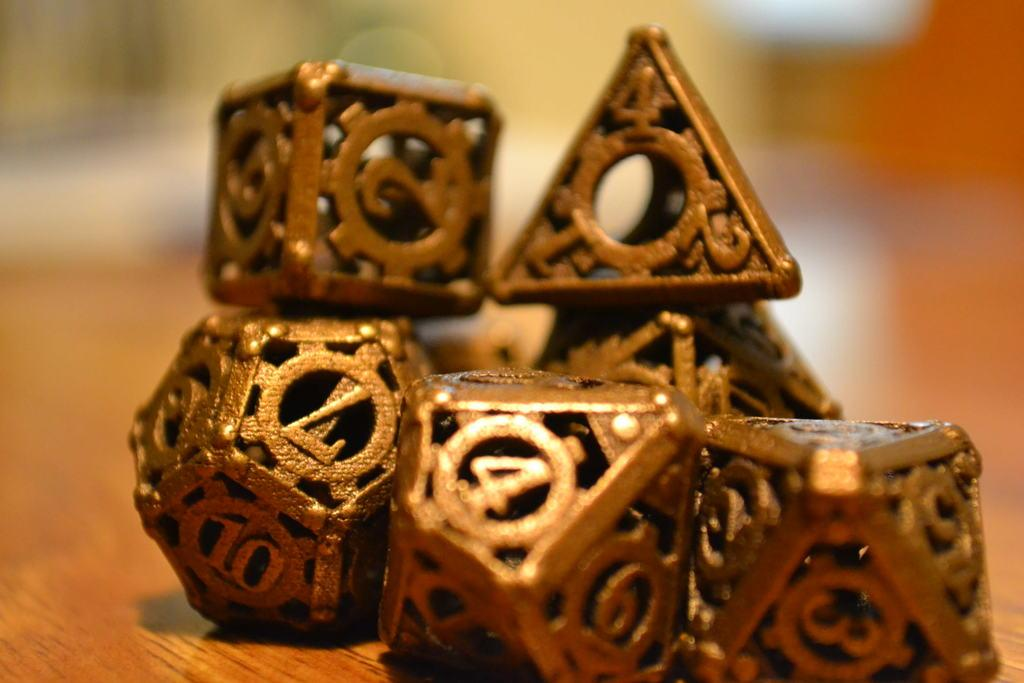What can be seen on the table in the image? There are decorations on the table in the image. What type of authority is present in the image? There is no authority figure present in the image; it only shows decorations on a table. 